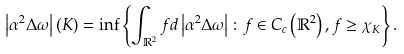<formula> <loc_0><loc_0><loc_500><loc_500>\left | \alpha ^ { 2 } \Delta \omega \right | \left ( K \right ) = \inf \left \{ \int _ { \mathbb { R } ^ { 2 } } f d \left | \alpha ^ { 2 } \Delta \omega \right | \colon f \in C _ { c } \left ( \mathbb { R } ^ { 2 } \right ) , f \geq \chi _ { K } \right \} .</formula> 